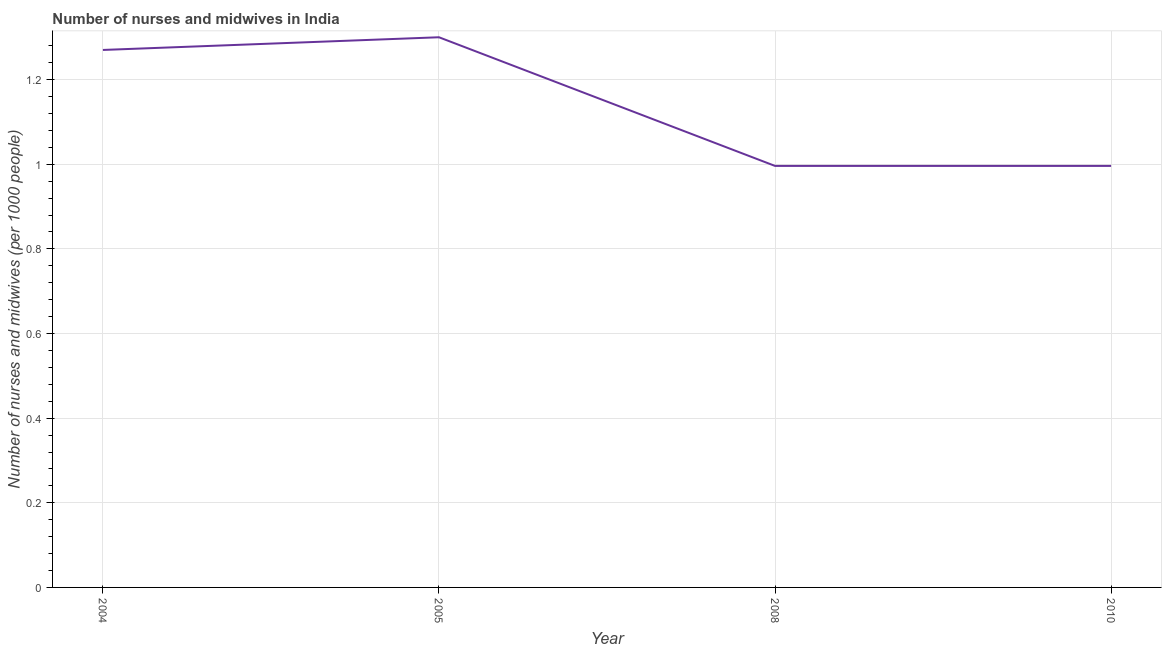What is the number of nurses and midwives in 2004?
Provide a short and direct response. 1.27. Across all years, what is the minimum number of nurses and midwives?
Provide a succinct answer. 1. What is the sum of the number of nurses and midwives?
Make the answer very short. 4.56. What is the difference between the number of nurses and midwives in 2005 and 2008?
Give a very brief answer. 0.3. What is the average number of nurses and midwives per year?
Offer a very short reply. 1.14. What is the median number of nurses and midwives?
Give a very brief answer. 1.13. In how many years, is the number of nurses and midwives greater than 0.36 ?
Provide a succinct answer. 4. Do a majority of the years between 2010 and 2008 (inclusive) have number of nurses and midwives greater than 0.52 ?
Offer a terse response. No. What is the ratio of the number of nurses and midwives in 2005 to that in 2010?
Your response must be concise. 1.31. What is the difference between the highest and the second highest number of nurses and midwives?
Provide a succinct answer. 0.03. What is the difference between the highest and the lowest number of nurses and midwives?
Your response must be concise. 0.3. How many lines are there?
Give a very brief answer. 1. How many years are there in the graph?
Make the answer very short. 4. What is the difference between two consecutive major ticks on the Y-axis?
Keep it short and to the point. 0.2. Does the graph contain grids?
Keep it short and to the point. Yes. What is the title of the graph?
Your response must be concise. Number of nurses and midwives in India. What is the label or title of the Y-axis?
Offer a very short reply. Number of nurses and midwives (per 1000 people). What is the Number of nurses and midwives (per 1000 people) of 2004?
Ensure brevity in your answer.  1.27. What is the Number of nurses and midwives (per 1000 people) of 2005?
Provide a succinct answer. 1.3. What is the Number of nurses and midwives (per 1000 people) in 2010?
Keep it short and to the point. 1. What is the difference between the Number of nurses and midwives (per 1000 people) in 2004 and 2005?
Provide a succinct answer. -0.03. What is the difference between the Number of nurses and midwives (per 1000 people) in 2004 and 2008?
Offer a very short reply. 0.27. What is the difference between the Number of nurses and midwives (per 1000 people) in 2004 and 2010?
Give a very brief answer. 0.27. What is the difference between the Number of nurses and midwives (per 1000 people) in 2005 and 2008?
Make the answer very short. 0.3. What is the difference between the Number of nurses and midwives (per 1000 people) in 2005 and 2010?
Provide a succinct answer. 0.3. What is the difference between the Number of nurses and midwives (per 1000 people) in 2008 and 2010?
Keep it short and to the point. 0. What is the ratio of the Number of nurses and midwives (per 1000 people) in 2004 to that in 2008?
Your answer should be compact. 1.27. What is the ratio of the Number of nurses and midwives (per 1000 people) in 2004 to that in 2010?
Offer a very short reply. 1.27. What is the ratio of the Number of nurses and midwives (per 1000 people) in 2005 to that in 2008?
Your response must be concise. 1.3. What is the ratio of the Number of nurses and midwives (per 1000 people) in 2005 to that in 2010?
Your answer should be very brief. 1.3. What is the ratio of the Number of nurses and midwives (per 1000 people) in 2008 to that in 2010?
Keep it short and to the point. 1. 